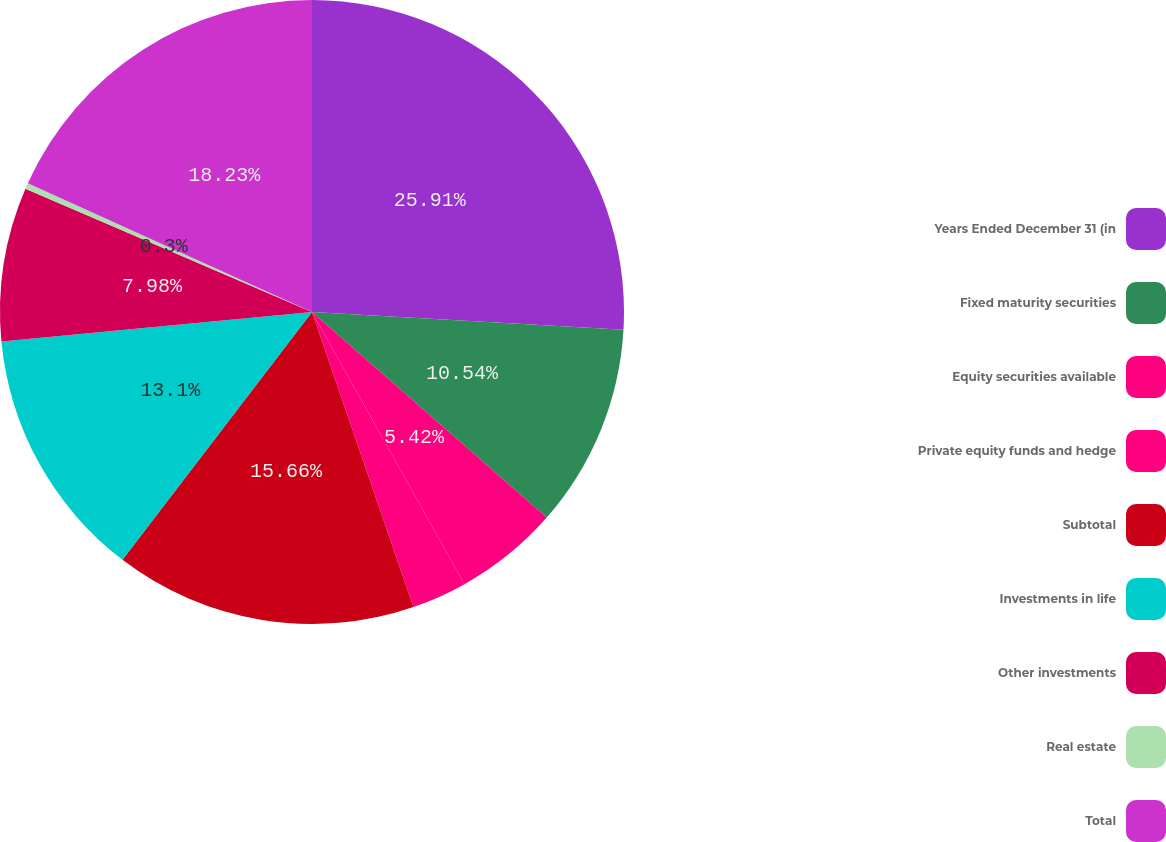<chart> <loc_0><loc_0><loc_500><loc_500><pie_chart><fcel>Years Ended December 31 (in<fcel>Fixed maturity securities<fcel>Equity securities available<fcel>Private equity funds and hedge<fcel>Subtotal<fcel>Investments in life<fcel>Other investments<fcel>Real estate<fcel>Total<nl><fcel>25.91%<fcel>10.54%<fcel>5.42%<fcel>2.86%<fcel>15.66%<fcel>13.1%<fcel>7.98%<fcel>0.3%<fcel>18.23%<nl></chart> 